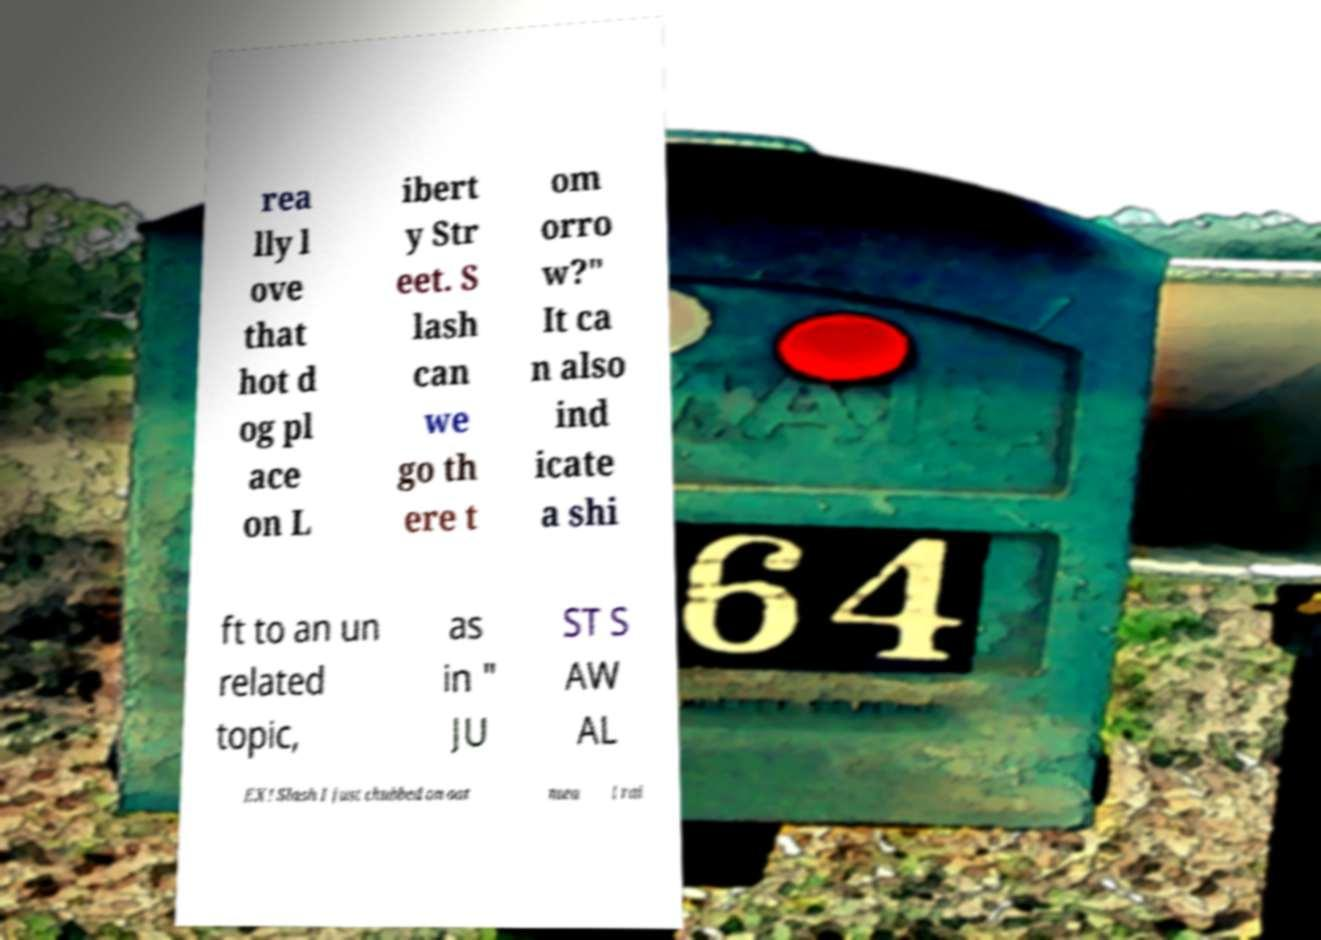Please read and relay the text visible in this image. What does it say? rea lly l ove that hot d og pl ace on L ibert y Str eet. S lash can we go th ere t om orro w?" It ca n also ind icate a shi ft to an un related topic, as in " JU ST S AW AL EX! Slash I just chubbed on oat mea l rai 